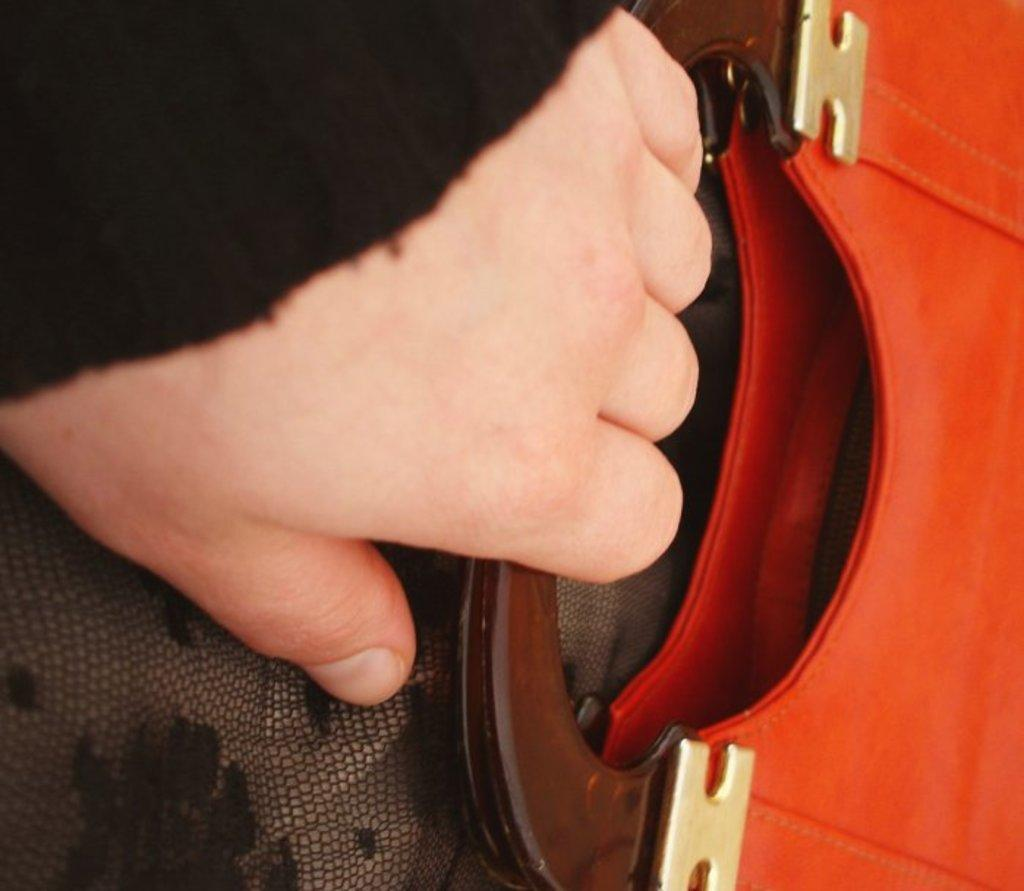What object is being held by a person in the image? There is a bag in the image, and it is held by a person. What can be said about the appearance of the bag? The bag is red in color. What type of fruit is being held in the person's other hand in the image? There is no fruit visible in the image; only the red bag is present. 